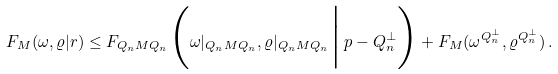Convert formula to latex. <formula><loc_0><loc_0><loc_500><loc_500>F _ { M } ( \omega , \varrho | r ) \leq F _ { Q _ { n } M Q _ { n } } \Big ( \omega | _ { Q _ { n } M Q _ { n } } , \varrho | _ { Q _ { n } M Q _ { n } } \Big | \, p - Q _ { n } ^ { \perp } \Big ) + F _ { M } ( \omega ^ { Q _ { n } ^ { \perp } } , \varrho ^ { Q _ { n } ^ { \perp } } ) \, .</formula> 